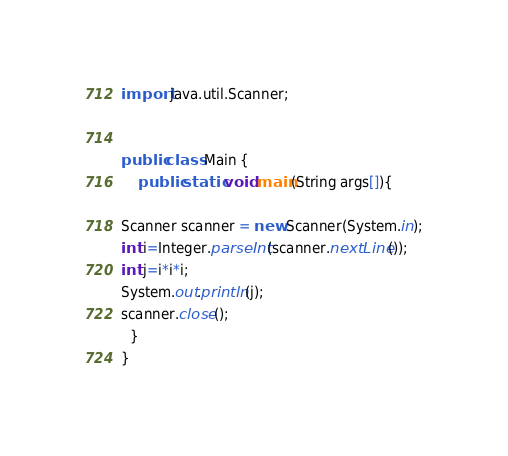<code> <loc_0><loc_0><loc_500><loc_500><_Java_>import java.util.Scanner;


public class Main {
    public static void main(String args[]){
	 	
Scanner scanner = new Scanner(System.in);
int i=Integer.parseInt(scanner.nextLine());
int j=i*i*i;
System.out.println(j);
scanner.close();
  }
}

</code> 